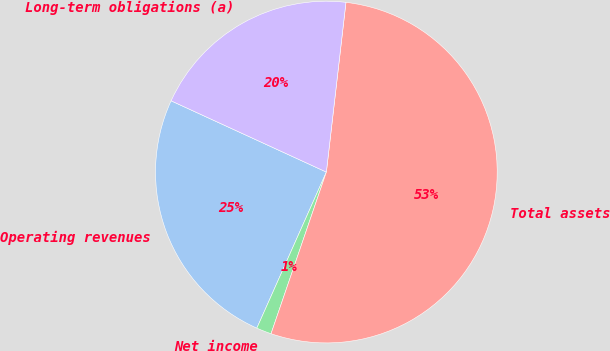<chart> <loc_0><loc_0><loc_500><loc_500><pie_chart><fcel>Operating revenues<fcel>Net income<fcel>Total assets<fcel>Long-term obligations (a)<nl><fcel>25.18%<fcel>1.42%<fcel>53.42%<fcel>19.98%<nl></chart> 